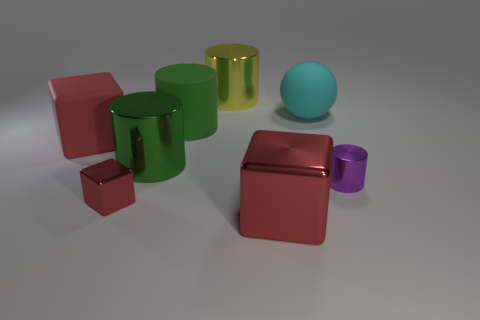Which object appears to be the smallest? The smallest object appears to be the small purple cylinder, based on its relative size compared to the other objects in the image, which include larger cylinders and a cube. And how can you tell that it's smaller than the others? By observing the objects in relation to each other and assuming they are at similar distances from the viewer, the small purple cylinder has a smaller base diameter and height compared to the other cylindrical and cubic shapes, which makes it look smaller in scale. 